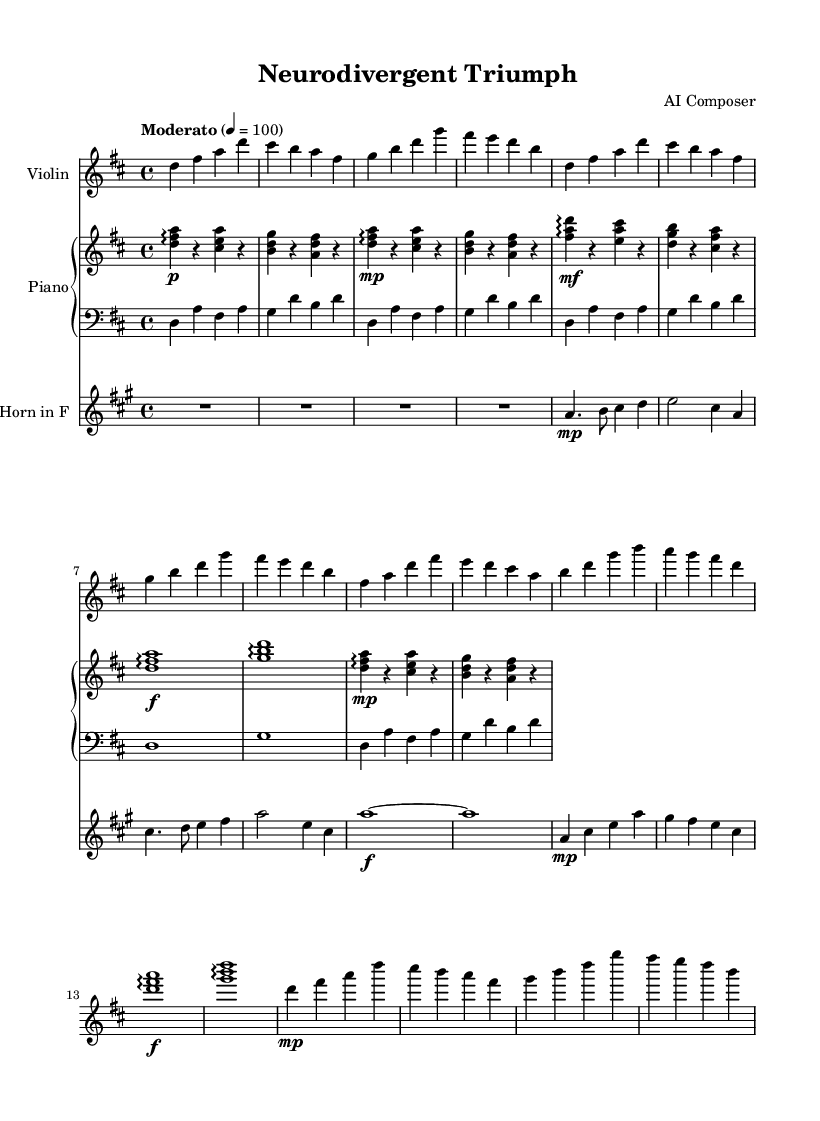What is the key signature of this music? The key signature is indicated at the beginning of the staff, showing two sharps (F# and C#), defining the key of D major.
Answer: D major What is the time signature of this piece? The time signature is represented at the beginning of the music, showing 4 beats per measure, which is indicated as 4/4.
Answer: 4/4 What is the tempo marking for this score? The tempo marking appears at the beginning of the score, indicating the piece should be played at a moderate speed of 100 beats per minute.
Answer: Moderato 100 How many measures are there in the piece? By counting the measures from the beginning to the end of the scores provided, including repeats, there are a total of 17 measures.
Answer: 17 What dynamic markings are present in the score? Dynamic markings are noted throughout the score; for example, the violin reaches a forte at the climax, as indicated by "f", while the beginning of sections specifies "p" (piano) and "mp" (mezzo-piano) dynamics.
Answer: p, mp, f What section of the piece features the climax? The climax is identified in the score where the dynamics peak, indicated by the use of a whole note with a forte dynamic marking at the section with the notes D, F#, and A.
Answer: Climax 